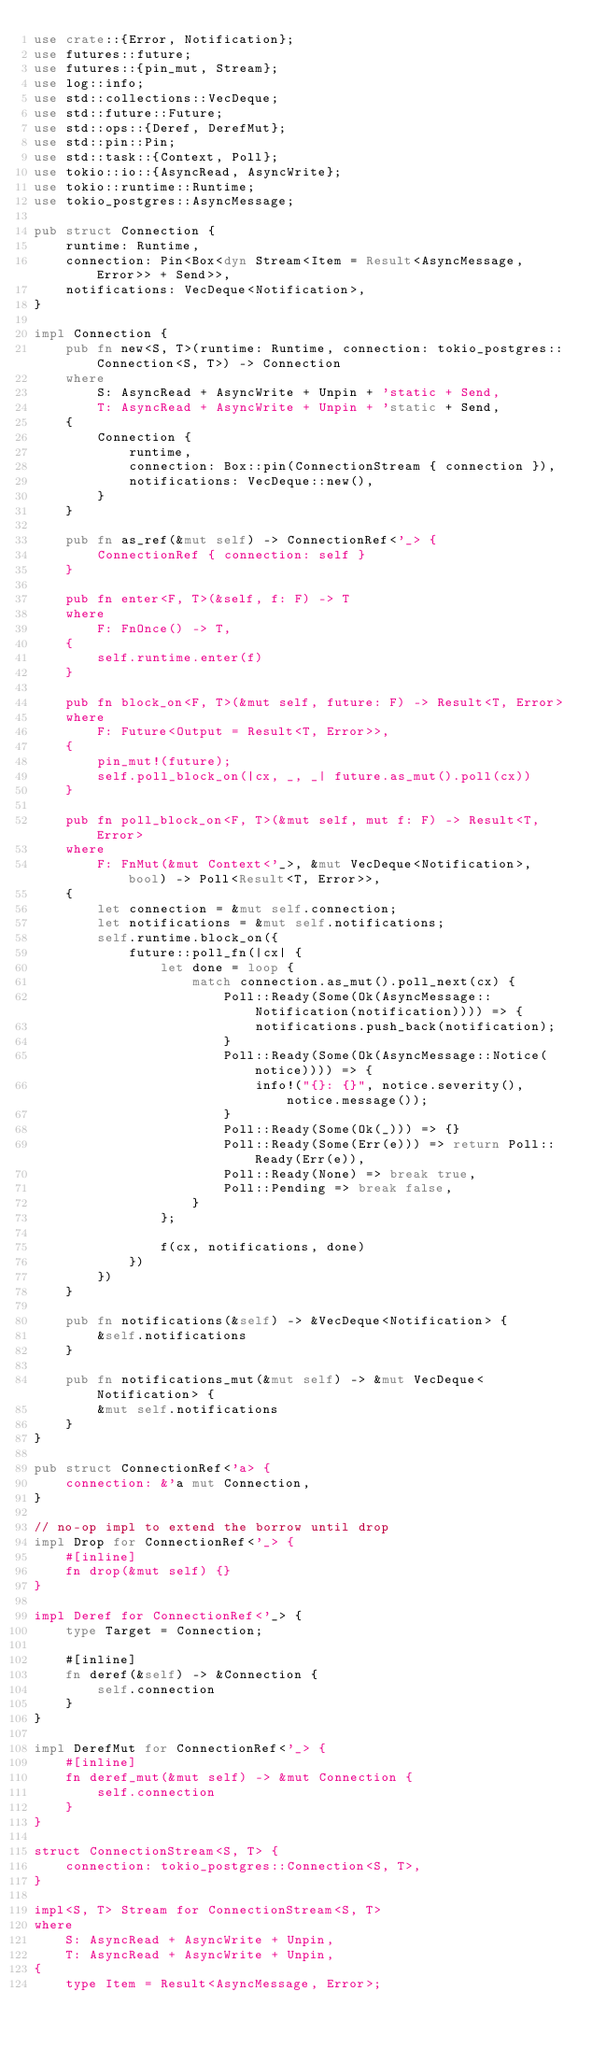Convert code to text. <code><loc_0><loc_0><loc_500><loc_500><_Rust_>use crate::{Error, Notification};
use futures::future;
use futures::{pin_mut, Stream};
use log::info;
use std::collections::VecDeque;
use std::future::Future;
use std::ops::{Deref, DerefMut};
use std::pin::Pin;
use std::task::{Context, Poll};
use tokio::io::{AsyncRead, AsyncWrite};
use tokio::runtime::Runtime;
use tokio_postgres::AsyncMessage;

pub struct Connection {
    runtime: Runtime,
    connection: Pin<Box<dyn Stream<Item = Result<AsyncMessage, Error>> + Send>>,
    notifications: VecDeque<Notification>,
}

impl Connection {
    pub fn new<S, T>(runtime: Runtime, connection: tokio_postgres::Connection<S, T>) -> Connection
    where
        S: AsyncRead + AsyncWrite + Unpin + 'static + Send,
        T: AsyncRead + AsyncWrite + Unpin + 'static + Send,
    {
        Connection {
            runtime,
            connection: Box::pin(ConnectionStream { connection }),
            notifications: VecDeque::new(),
        }
    }

    pub fn as_ref(&mut self) -> ConnectionRef<'_> {
        ConnectionRef { connection: self }
    }

    pub fn enter<F, T>(&self, f: F) -> T
    where
        F: FnOnce() -> T,
    {
        self.runtime.enter(f)
    }

    pub fn block_on<F, T>(&mut self, future: F) -> Result<T, Error>
    where
        F: Future<Output = Result<T, Error>>,
    {
        pin_mut!(future);
        self.poll_block_on(|cx, _, _| future.as_mut().poll(cx))
    }

    pub fn poll_block_on<F, T>(&mut self, mut f: F) -> Result<T, Error>
    where
        F: FnMut(&mut Context<'_>, &mut VecDeque<Notification>, bool) -> Poll<Result<T, Error>>,
    {
        let connection = &mut self.connection;
        let notifications = &mut self.notifications;
        self.runtime.block_on({
            future::poll_fn(|cx| {
                let done = loop {
                    match connection.as_mut().poll_next(cx) {
                        Poll::Ready(Some(Ok(AsyncMessage::Notification(notification)))) => {
                            notifications.push_back(notification);
                        }
                        Poll::Ready(Some(Ok(AsyncMessage::Notice(notice)))) => {
                            info!("{}: {}", notice.severity(), notice.message());
                        }
                        Poll::Ready(Some(Ok(_))) => {}
                        Poll::Ready(Some(Err(e))) => return Poll::Ready(Err(e)),
                        Poll::Ready(None) => break true,
                        Poll::Pending => break false,
                    }
                };

                f(cx, notifications, done)
            })
        })
    }

    pub fn notifications(&self) -> &VecDeque<Notification> {
        &self.notifications
    }

    pub fn notifications_mut(&mut self) -> &mut VecDeque<Notification> {
        &mut self.notifications
    }
}

pub struct ConnectionRef<'a> {
    connection: &'a mut Connection,
}

// no-op impl to extend the borrow until drop
impl Drop for ConnectionRef<'_> {
    #[inline]
    fn drop(&mut self) {}
}

impl Deref for ConnectionRef<'_> {
    type Target = Connection;

    #[inline]
    fn deref(&self) -> &Connection {
        self.connection
    }
}

impl DerefMut for ConnectionRef<'_> {
    #[inline]
    fn deref_mut(&mut self) -> &mut Connection {
        self.connection
    }
}

struct ConnectionStream<S, T> {
    connection: tokio_postgres::Connection<S, T>,
}

impl<S, T> Stream for ConnectionStream<S, T>
where
    S: AsyncRead + AsyncWrite + Unpin,
    T: AsyncRead + AsyncWrite + Unpin,
{
    type Item = Result<AsyncMessage, Error>;
</code> 